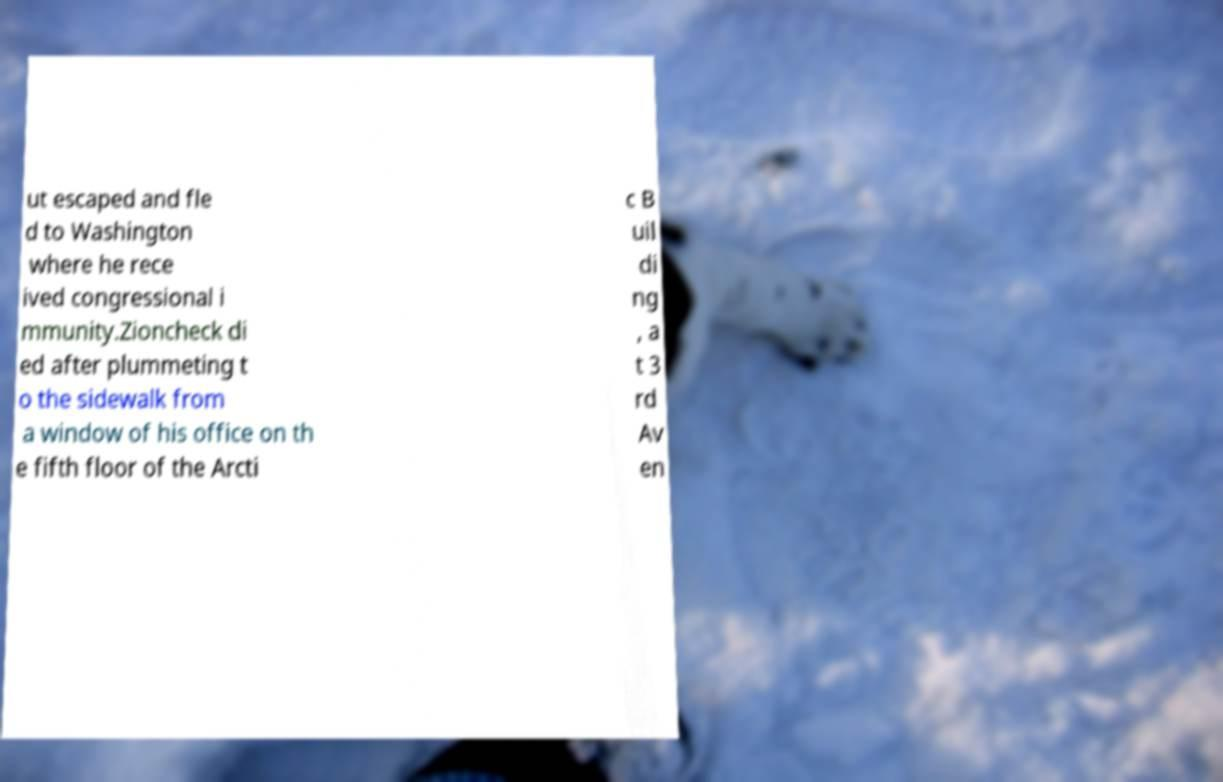There's text embedded in this image that I need extracted. Can you transcribe it verbatim? ut escaped and fle d to Washington where he rece ived congressional i mmunity.Zioncheck di ed after plummeting t o the sidewalk from a window of his office on th e fifth floor of the Arcti c B uil di ng , a t 3 rd Av en 